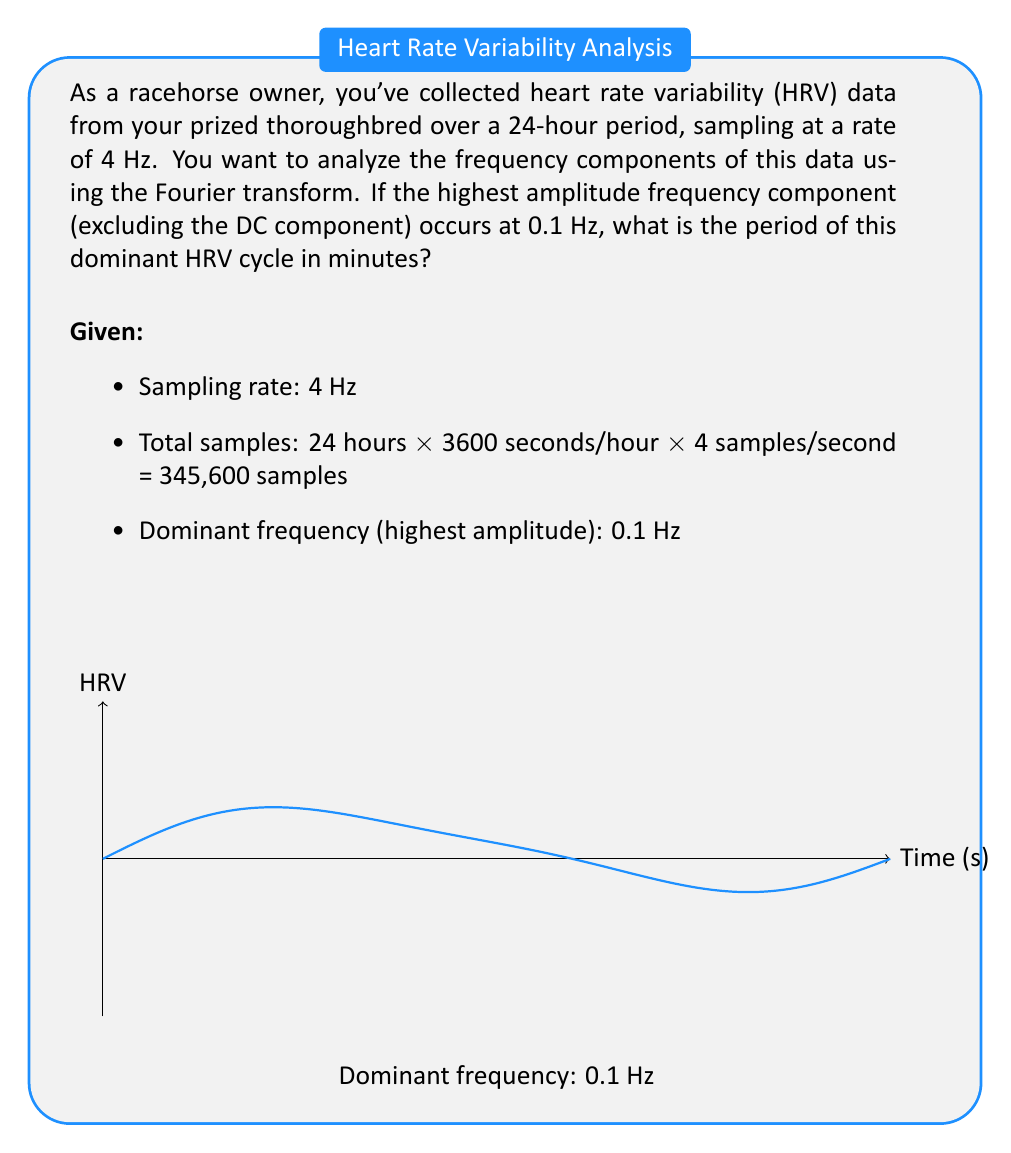What is the answer to this math problem? Let's approach this step-by-step:

1) The Fourier transform allows us to decompose a time-domain signal into its frequency components. In this case, we've already been given the result that the dominant frequency is 0.1 Hz.

2) To find the period of this dominant cycle, we need to use the relationship between frequency (f) and period (T):

   $$f = \frac{1}{T}$$

3) Rearranging this equation, we get:

   $$T = \frac{1}{f}$$

4) Substituting our dominant frequency of 0.1 Hz:

   $$T = \frac{1}{0.1 \text{ Hz}} = 10 \text{ seconds}$$

5) However, the question asks for the period in minutes. So we need to convert:

   $$10 \text{ seconds} = \frac{10}{60} \text{ minutes} = \frac{1}{6} \text{ minutes}$$

Therefore, the period of the dominant HRV cycle is 1/6 minutes.
Answer: $\frac{1}{6}$ minutes 